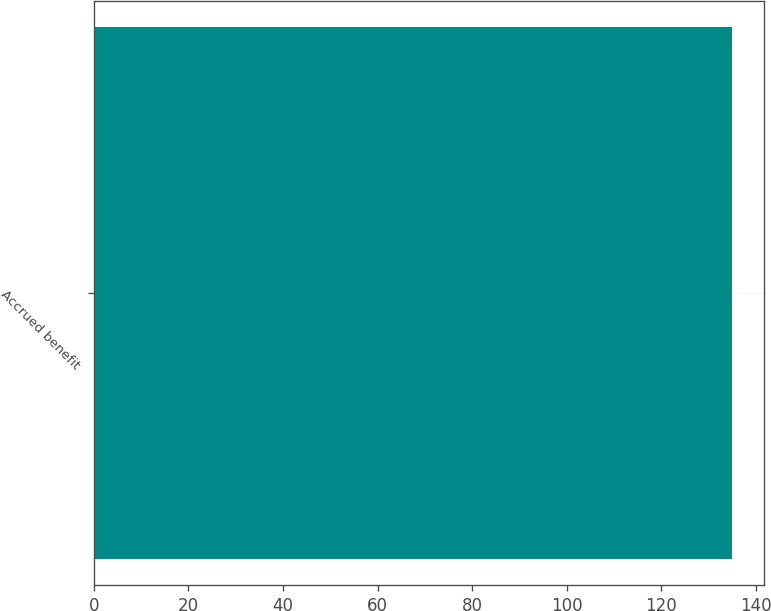Convert chart. <chart><loc_0><loc_0><loc_500><loc_500><bar_chart><fcel>Accrued benefit<nl><fcel>135<nl></chart> 